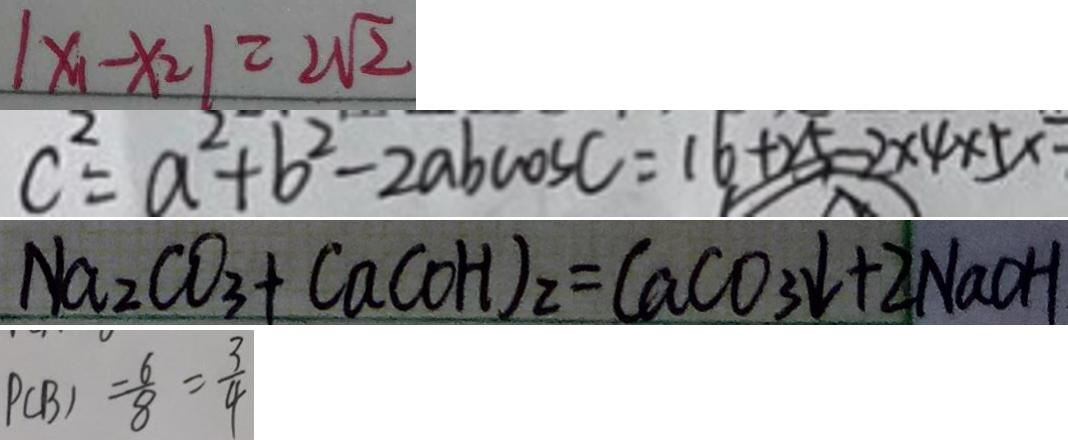Convert formula to latex. <formula><loc_0><loc_0><loc_500><loc_500>\vert x _ { 1 } - x _ { 2 } \vert = 2 \sqrt { 2 } 
 c ^ { 2 } = a ^ { 2 } + b ^ { 2 } - 2 a b \cos c = 1 6 + 2 5 - 2 \times 4 \times 5 \times 
 N a _ { 2 } C O _ { 3 } + C a ( O H ) _ { 2 } = C a C O _ { 3 } \downarrow + 2 N a C H 
 P ( B ) = \frac { 6 } { 8 } = \frac { 3 } { 4 }</formula> 